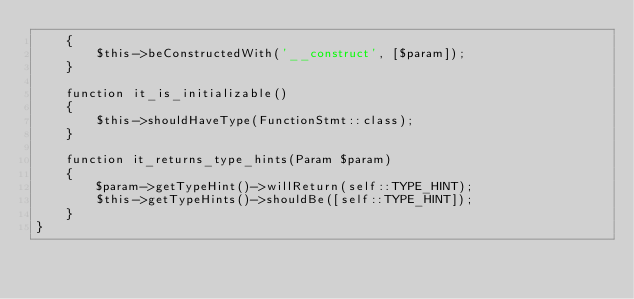<code> <loc_0><loc_0><loc_500><loc_500><_PHP_>    {
        $this->beConstructedWith('__construct', [$param]);
    }

    function it_is_initializable()
    {
        $this->shouldHaveType(FunctionStmt::class);
    }

    function it_returns_type_hints(Param $param)
    {
        $param->getTypeHint()->willReturn(self::TYPE_HINT);
        $this->getTypeHints()->shouldBe([self::TYPE_HINT]);
    }
}
</code> 